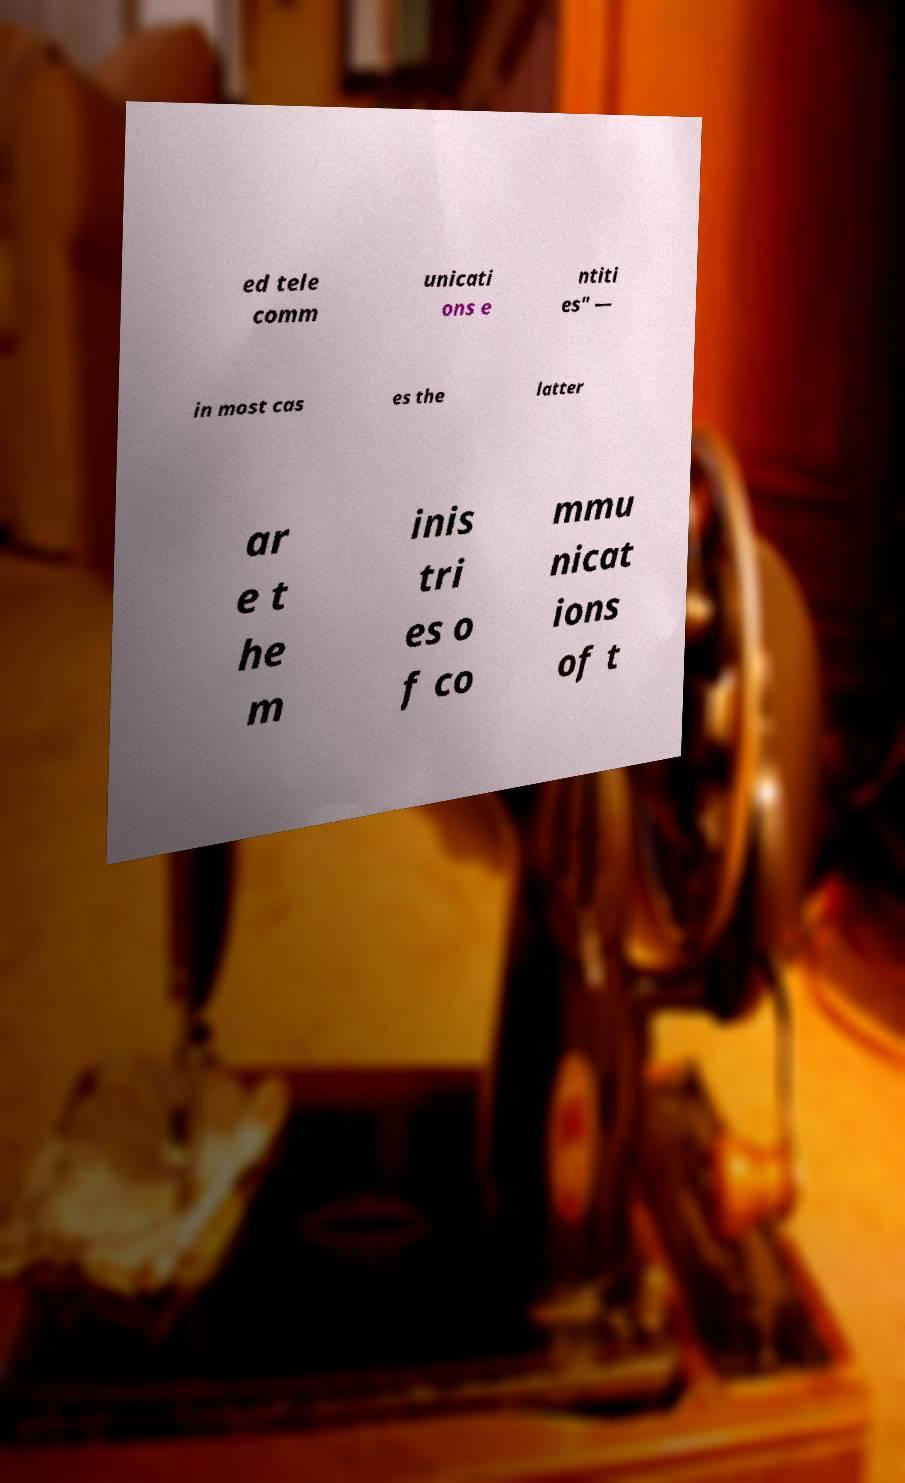Could you extract and type out the text from this image? ed tele comm unicati ons e ntiti es" — in most cas es the latter ar e t he m inis tri es o f co mmu nicat ions of t 